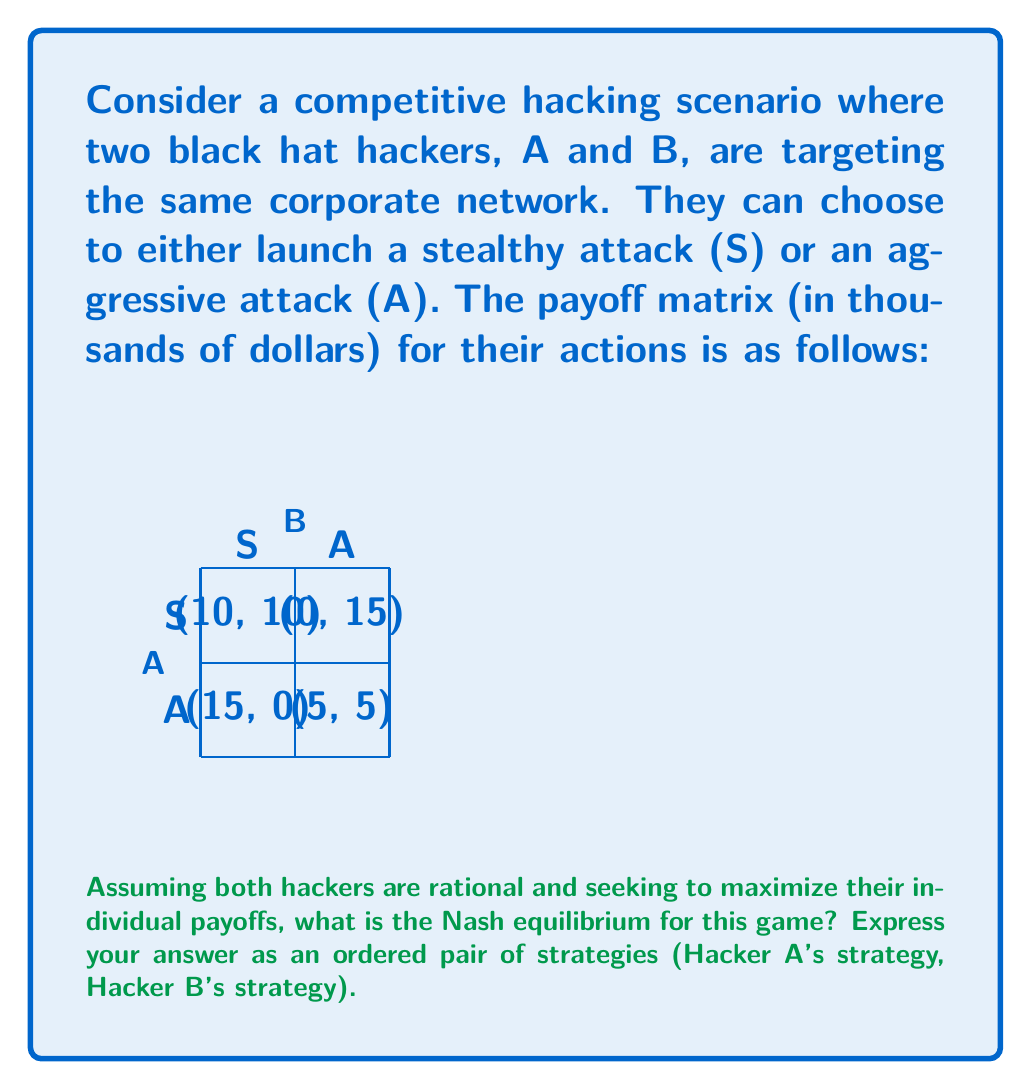Could you help me with this problem? To find the Nash equilibrium, we need to analyze each hacker's best response to the other's strategy:

1. If Hacker B chooses S:
   - If A chooses S, A gets 10
   - If A chooses A, A gets 15
   A's best response to B's S is A

2. If Hacker B chooses A:
   - If A chooses S, A gets 0
   - If A chooses A, A gets 5
   A's best response to B's A is A

3. If Hacker A chooses S:
   - If B chooses S, B gets 10
   - If B chooses A, B gets 15
   B's best response to A's S is A

4. If Hacker A chooses A:
   - If B chooses S, B gets 0
   - If B chooses A, B gets 5
   B's best response to A's A is A

From this analysis, we can see that regardless of what the other hacker does, both A and B will always choose the aggressive attack (A) strategy. This is because A is the dominant strategy for both players.

In game theory, a Nash equilibrium occurs when each player is making the best decision for themselves, given what the other players are doing. In this case, (A, A) is the Nash equilibrium because neither player can unilaterally change their strategy to improve their payoff.

The Nash equilibrium can be mathematically represented as:

$$\forall i, s_i^* = \arg\max_{s_i} u_i(s_i, s_{-i}^*)$$

Where $s_i^*$ is the equilibrium strategy for player $i$, $s_{-i}^*$ are the equilibrium strategies of all other players, and $u_i$ is the utility function for player $i$.

In this case, for both players:

$$A = \arg\max_{s_i \in \{S, A\}} u_i(s_i, A)$$

Therefore, the Nash equilibrium is (A, A).
Answer: (A, A) 